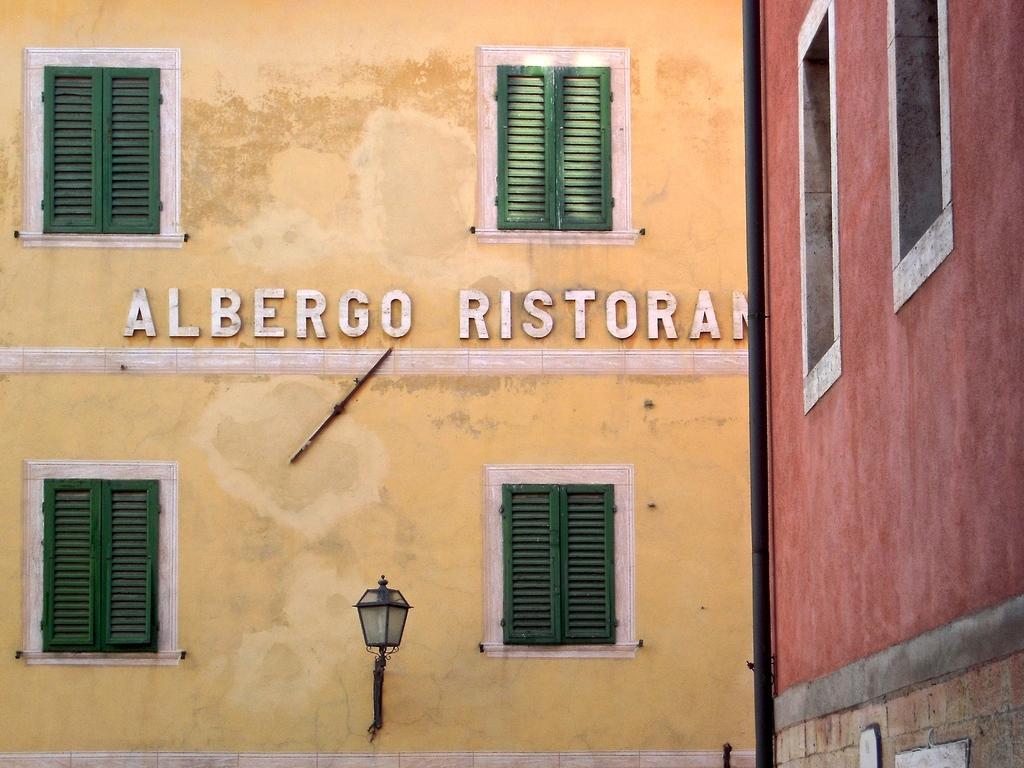How would you summarize this image in a sentence or two? In this picture there are buildings. At the back there is a yellow color painting on the wall and there are windows and there is a light and pipe and text on the wall. On the right side of the image there is a red painting on the wall. 